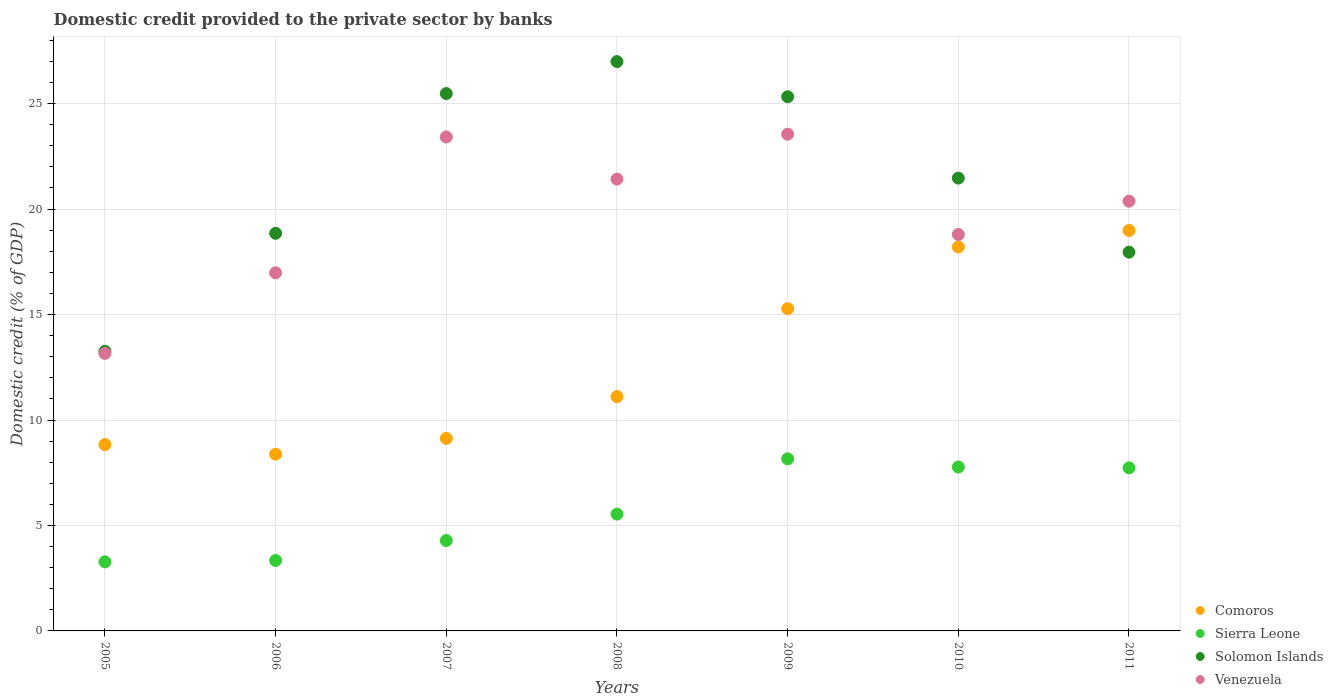Is the number of dotlines equal to the number of legend labels?
Keep it short and to the point. Yes. What is the domestic credit provided to the private sector by banks in Comoros in 2010?
Make the answer very short. 18.21. Across all years, what is the maximum domestic credit provided to the private sector by banks in Venezuela?
Your answer should be compact. 23.55. Across all years, what is the minimum domestic credit provided to the private sector by banks in Sierra Leone?
Your response must be concise. 3.28. In which year was the domestic credit provided to the private sector by banks in Solomon Islands maximum?
Offer a very short reply. 2008. In which year was the domestic credit provided to the private sector by banks in Sierra Leone minimum?
Make the answer very short. 2005. What is the total domestic credit provided to the private sector by banks in Solomon Islands in the graph?
Your answer should be very brief. 149.33. What is the difference between the domestic credit provided to the private sector by banks in Comoros in 2010 and that in 2011?
Make the answer very short. -0.78. What is the difference between the domestic credit provided to the private sector by banks in Sierra Leone in 2005 and the domestic credit provided to the private sector by banks in Venezuela in 2010?
Make the answer very short. -15.52. What is the average domestic credit provided to the private sector by banks in Sierra Leone per year?
Give a very brief answer. 5.73. In the year 2010, what is the difference between the domestic credit provided to the private sector by banks in Venezuela and domestic credit provided to the private sector by banks in Sierra Leone?
Provide a short and direct response. 11.03. In how many years, is the domestic credit provided to the private sector by banks in Sierra Leone greater than 27 %?
Your answer should be compact. 0. What is the ratio of the domestic credit provided to the private sector by banks in Solomon Islands in 2007 to that in 2008?
Keep it short and to the point. 0.94. Is the domestic credit provided to the private sector by banks in Solomon Islands in 2007 less than that in 2009?
Keep it short and to the point. No. Is the difference between the domestic credit provided to the private sector by banks in Venezuela in 2010 and 2011 greater than the difference between the domestic credit provided to the private sector by banks in Sierra Leone in 2010 and 2011?
Provide a succinct answer. No. What is the difference between the highest and the second highest domestic credit provided to the private sector by banks in Solomon Islands?
Your answer should be compact. 1.52. What is the difference between the highest and the lowest domestic credit provided to the private sector by banks in Comoros?
Your answer should be compact. 10.61. In how many years, is the domestic credit provided to the private sector by banks in Solomon Islands greater than the average domestic credit provided to the private sector by banks in Solomon Islands taken over all years?
Ensure brevity in your answer.  4. Is the sum of the domestic credit provided to the private sector by banks in Comoros in 2007 and 2008 greater than the maximum domestic credit provided to the private sector by banks in Solomon Islands across all years?
Keep it short and to the point. No. Is it the case that in every year, the sum of the domestic credit provided to the private sector by banks in Venezuela and domestic credit provided to the private sector by banks in Sierra Leone  is greater than the sum of domestic credit provided to the private sector by banks in Solomon Islands and domestic credit provided to the private sector by banks in Comoros?
Offer a very short reply. Yes. Is it the case that in every year, the sum of the domestic credit provided to the private sector by banks in Solomon Islands and domestic credit provided to the private sector by banks in Venezuela  is greater than the domestic credit provided to the private sector by banks in Sierra Leone?
Make the answer very short. Yes. Is the domestic credit provided to the private sector by banks in Venezuela strictly greater than the domestic credit provided to the private sector by banks in Sierra Leone over the years?
Provide a succinct answer. Yes. Is the domestic credit provided to the private sector by banks in Venezuela strictly less than the domestic credit provided to the private sector by banks in Sierra Leone over the years?
Provide a succinct answer. No. What is the difference between two consecutive major ticks on the Y-axis?
Your answer should be compact. 5. Does the graph contain grids?
Provide a succinct answer. Yes. How many legend labels are there?
Provide a succinct answer. 4. What is the title of the graph?
Provide a short and direct response. Domestic credit provided to the private sector by banks. What is the label or title of the Y-axis?
Offer a very short reply. Domestic credit (% of GDP). What is the Domestic credit (% of GDP) in Comoros in 2005?
Offer a terse response. 8.83. What is the Domestic credit (% of GDP) of Sierra Leone in 2005?
Provide a succinct answer. 3.28. What is the Domestic credit (% of GDP) of Solomon Islands in 2005?
Give a very brief answer. 13.25. What is the Domestic credit (% of GDP) in Venezuela in 2005?
Offer a terse response. 13.16. What is the Domestic credit (% of GDP) of Comoros in 2006?
Give a very brief answer. 8.38. What is the Domestic credit (% of GDP) of Sierra Leone in 2006?
Offer a terse response. 3.34. What is the Domestic credit (% of GDP) in Solomon Islands in 2006?
Keep it short and to the point. 18.85. What is the Domestic credit (% of GDP) of Venezuela in 2006?
Offer a very short reply. 16.98. What is the Domestic credit (% of GDP) in Comoros in 2007?
Your answer should be compact. 9.13. What is the Domestic credit (% of GDP) of Sierra Leone in 2007?
Offer a very short reply. 4.28. What is the Domestic credit (% of GDP) in Solomon Islands in 2007?
Provide a succinct answer. 25.48. What is the Domestic credit (% of GDP) in Venezuela in 2007?
Your answer should be very brief. 23.42. What is the Domestic credit (% of GDP) of Comoros in 2008?
Ensure brevity in your answer.  11.11. What is the Domestic credit (% of GDP) in Sierra Leone in 2008?
Offer a very short reply. 5.54. What is the Domestic credit (% of GDP) of Solomon Islands in 2008?
Make the answer very short. 26.99. What is the Domestic credit (% of GDP) of Venezuela in 2008?
Offer a very short reply. 21.42. What is the Domestic credit (% of GDP) of Comoros in 2009?
Keep it short and to the point. 15.28. What is the Domestic credit (% of GDP) in Sierra Leone in 2009?
Keep it short and to the point. 8.16. What is the Domestic credit (% of GDP) in Solomon Islands in 2009?
Your answer should be very brief. 25.33. What is the Domestic credit (% of GDP) of Venezuela in 2009?
Your answer should be compact. 23.55. What is the Domestic credit (% of GDP) of Comoros in 2010?
Provide a short and direct response. 18.21. What is the Domestic credit (% of GDP) in Sierra Leone in 2010?
Make the answer very short. 7.77. What is the Domestic credit (% of GDP) in Solomon Islands in 2010?
Make the answer very short. 21.47. What is the Domestic credit (% of GDP) in Venezuela in 2010?
Keep it short and to the point. 18.8. What is the Domestic credit (% of GDP) of Comoros in 2011?
Give a very brief answer. 18.99. What is the Domestic credit (% of GDP) of Sierra Leone in 2011?
Keep it short and to the point. 7.73. What is the Domestic credit (% of GDP) of Solomon Islands in 2011?
Your answer should be very brief. 17.96. What is the Domestic credit (% of GDP) in Venezuela in 2011?
Make the answer very short. 20.37. Across all years, what is the maximum Domestic credit (% of GDP) of Comoros?
Your answer should be very brief. 18.99. Across all years, what is the maximum Domestic credit (% of GDP) of Sierra Leone?
Your answer should be very brief. 8.16. Across all years, what is the maximum Domestic credit (% of GDP) in Solomon Islands?
Provide a succinct answer. 26.99. Across all years, what is the maximum Domestic credit (% of GDP) of Venezuela?
Your response must be concise. 23.55. Across all years, what is the minimum Domestic credit (% of GDP) in Comoros?
Give a very brief answer. 8.38. Across all years, what is the minimum Domestic credit (% of GDP) in Sierra Leone?
Provide a succinct answer. 3.28. Across all years, what is the minimum Domestic credit (% of GDP) in Solomon Islands?
Your answer should be compact. 13.25. Across all years, what is the minimum Domestic credit (% of GDP) of Venezuela?
Provide a short and direct response. 13.16. What is the total Domestic credit (% of GDP) in Comoros in the graph?
Offer a terse response. 89.92. What is the total Domestic credit (% of GDP) of Sierra Leone in the graph?
Offer a terse response. 40.1. What is the total Domestic credit (% of GDP) in Solomon Islands in the graph?
Your answer should be very brief. 149.33. What is the total Domestic credit (% of GDP) in Venezuela in the graph?
Offer a very short reply. 137.7. What is the difference between the Domestic credit (% of GDP) in Comoros in 2005 and that in 2006?
Your answer should be very brief. 0.45. What is the difference between the Domestic credit (% of GDP) of Sierra Leone in 2005 and that in 2006?
Ensure brevity in your answer.  -0.06. What is the difference between the Domestic credit (% of GDP) of Solomon Islands in 2005 and that in 2006?
Provide a succinct answer. -5.6. What is the difference between the Domestic credit (% of GDP) in Venezuela in 2005 and that in 2006?
Your response must be concise. -3.82. What is the difference between the Domestic credit (% of GDP) in Comoros in 2005 and that in 2007?
Offer a very short reply. -0.29. What is the difference between the Domestic credit (% of GDP) in Sierra Leone in 2005 and that in 2007?
Offer a terse response. -1.01. What is the difference between the Domestic credit (% of GDP) in Solomon Islands in 2005 and that in 2007?
Keep it short and to the point. -12.22. What is the difference between the Domestic credit (% of GDP) of Venezuela in 2005 and that in 2007?
Provide a succinct answer. -10.26. What is the difference between the Domestic credit (% of GDP) of Comoros in 2005 and that in 2008?
Give a very brief answer. -2.27. What is the difference between the Domestic credit (% of GDP) of Sierra Leone in 2005 and that in 2008?
Offer a very short reply. -2.26. What is the difference between the Domestic credit (% of GDP) in Solomon Islands in 2005 and that in 2008?
Your response must be concise. -13.74. What is the difference between the Domestic credit (% of GDP) in Venezuela in 2005 and that in 2008?
Offer a terse response. -8.26. What is the difference between the Domestic credit (% of GDP) in Comoros in 2005 and that in 2009?
Ensure brevity in your answer.  -6.44. What is the difference between the Domestic credit (% of GDP) of Sierra Leone in 2005 and that in 2009?
Provide a short and direct response. -4.88. What is the difference between the Domestic credit (% of GDP) in Solomon Islands in 2005 and that in 2009?
Your answer should be very brief. -12.07. What is the difference between the Domestic credit (% of GDP) of Venezuela in 2005 and that in 2009?
Provide a succinct answer. -10.39. What is the difference between the Domestic credit (% of GDP) in Comoros in 2005 and that in 2010?
Give a very brief answer. -9.37. What is the difference between the Domestic credit (% of GDP) of Sierra Leone in 2005 and that in 2010?
Offer a very short reply. -4.5. What is the difference between the Domestic credit (% of GDP) of Solomon Islands in 2005 and that in 2010?
Your answer should be very brief. -8.21. What is the difference between the Domestic credit (% of GDP) of Venezuela in 2005 and that in 2010?
Your response must be concise. -5.64. What is the difference between the Domestic credit (% of GDP) in Comoros in 2005 and that in 2011?
Offer a very short reply. -10.15. What is the difference between the Domestic credit (% of GDP) of Sierra Leone in 2005 and that in 2011?
Provide a succinct answer. -4.46. What is the difference between the Domestic credit (% of GDP) in Solomon Islands in 2005 and that in 2011?
Give a very brief answer. -4.7. What is the difference between the Domestic credit (% of GDP) of Venezuela in 2005 and that in 2011?
Offer a terse response. -7.22. What is the difference between the Domestic credit (% of GDP) in Comoros in 2006 and that in 2007?
Your answer should be very brief. -0.75. What is the difference between the Domestic credit (% of GDP) of Sierra Leone in 2006 and that in 2007?
Provide a succinct answer. -0.95. What is the difference between the Domestic credit (% of GDP) in Solomon Islands in 2006 and that in 2007?
Give a very brief answer. -6.63. What is the difference between the Domestic credit (% of GDP) in Venezuela in 2006 and that in 2007?
Make the answer very short. -6.44. What is the difference between the Domestic credit (% of GDP) of Comoros in 2006 and that in 2008?
Give a very brief answer. -2.73. What is the difference between the Domestic credit (% of GDP) in Sierra Leone in 2006 and that in 2008?
Keep it short and to the point. -2.2. What is the difference between the Domestic credit (% of GDP) of Solomon Islands in 2006 and that in 2008?
Provide a succinct answer. -8.14. What is the difference between the Domestic credit (% of GDP) of Venezuela in 2006 and that in 2008?
Your response must be concise. -4.44. What is the difference between the Domestic credit (% of GDP) in Comoros in 2006 and that in 2009?
Your answer should be compact. -6.9. What is the difference between the Domestic credit (% of GDP) of Sierra Leone in 2006 and that in 2009?
Provide a short and direct response. -4.82. What is the difference between the Domestic credit (% of GDP) in Solomon Islands in 2006 and that in 2009?
Ensure brevity in your answer.  -6.47. What is the difference between the Domestic credit (% of GDP) of Venezuela in 2006 and that in 2009?
Keep it short and to the point. -6.57. What is the difference between the Domestic credit (% of GDP) in Comoros in 2006 and that in 2010?
Your answer should be compact. -9.83. What is the difference between the Domestic credit (% of GDP) of Sierra Leone in 2006 and that in 2010?
Give a very brief answer. -4.43. What is the difference between the Domestic credit (% of GDP) in Solomon Islands in 2006 and that in 2010?
Your response must be concise. -2.62. What is the difference between the Domestic credit (% of GDP) in Venezuela in 2006 and that in 2010?
Provide a succinct answer. -1.82. What is the difference between the Domestic credit (% of GDP) in Comoros in 2006 and that in 2011?
Give a very brief answer. -10.61. What is the difference between the Domestic credit (% of GDP) in Sierra Leone in 2006 and that in 2011?
Keep it short and to the point. -4.39. What is the difference between the Domestic credit (% of GDP) in Solomon Islands in 2006 and that in 2011?
Give a very brief answer. 0.89. What is the difference between the Domestic credit (% of GDP) of Venezuela in 2006 and that in 2011?
Your answer should be compact. -3.39. What is the difference between the Domestic credit (% of GDP) in Comoros in 2007 and that in 2008?
Provide a succinct answer. -1.98. What is the difference between the Domestic credit (% of GDP) of Sierra Leone in 2007 and that in 2008?
Provide a succinct answer. -1.25. What is the difference between the Domestic credit (% of GDP) in Solomon Islands in 2007 and that in 2008?
Your answer should be compact. -1.52. What is the difference between the Domestic credit (% of GDP) in Venezuela in 2007 and that in 2008?
Your answer should be compact. 2. What is the difference between the Domestic credit (% of GDP) in Comoros in 2007 and that in 2009?
Your answer should be compact. -6.15. What is the difference between the Domestic credit (% of GDP) in Sierra Leone in 2007 and that in 2009?
Provide a succinct answer. -3.87. What is the difference between the Domestic credit (% of GDP) of Solomon Islands in 2007 and that in 2009?
Give a very brief answer. 0.15. What is the difference between the Domestic credit (% of GDP) in Venezuela in 2007 and that in 2009?
Give a very brief answer. -0.13. What is the difference between the Domestic credit (% of GDP) of Comoros in 2007 and that in 2010?
Give a very brief answer. -9.08. What is the difference between the Domestic credit (% of GDP) in Sierra Leone in 2007 and that in 2010?
Your answer should be compact. -3.49. What is the difference between the Domestic credit (% of GDP) of Solomon Islands in 2007 and that in 2010?
Ensure brevity in your answer.  4.01. What is the difference between the Domestic credit (% of GDP) in Venezuela in 2007 and that in 2010?
Provide a succinct answer. 4.62. What is the difference between the Domestic credit (% of GDP) in Comoros in 2007 and that in 2011?
Offer a terse response. -9.86. What is the difference between the Domestic credit (% of GDP) of Sierra Leone in 2007 and that in 2011?
Your answer should be compact. -3.45. What is the difference between the Domestic credit (% of GDP) in Solomon Islands in 2007 and that in 2011?
Ensure brevity in your answer.  7.52. What is the difference between the Domestic credit (% of GDP) in Venezuela in 2007 and that in 2011?
Make the answer very short. 3.05. What is the difference between the Domestic credit (% of GDP) of Comoros in 2008 and that in 2009?
Your answer should be very brief. -4.17. What is the difference between the Domestic credit (% of GDP) of Sierra Leone in 2008 and that in 2009?
Offer a terse response. -2.62. What is the difference between the Domestic credit (% of GDP) of Solomon Islands in 2008 and that in 2009?
Offer a terse response. 1.67. What is the difference between the Domestic credit (% of GDP) of Venezuela in 2008 and that in 2009?
Keep it short and to the point. -2.13. What is the difference between the Domestic credit (% of GDP) of Comoros in 2008 and that in 2010?
Offer a terse response. -7.1. What is the difference between the Domestic credit (% of GDP) of Sierra Leone in 2008 and that in 2010?
Offer a very short reply. -2.23. What is the difference between the Domestic credit (% of GDP) in Solomon Islands in 2008 and that in 2010?
Ensure brevity in your answer.  5.52. What is the difference between the Domestic credit (% of GDP) in Venezuela in 2008 and that in 2010?
Offer a terse response. 2.62. What is the difference between the Domestic credit (% of GDP) of Comoros in 2008 and that in 2011?
Keep it short and to the point. -7.88. What is the difference between the Domestic credit (% of GDP) in Sierra Leone in 2008 and that in 2011?
Offer a very short reply. -2.19. What is the difference between the Domestic credit (% of GDP) in Solomon Islands in 2008 and that in 2011?
Provide a short and direct response. 9.04. What is the difference between the Domestic credit (% of GDP) of Venezuela in 2008 and that in 2011?
Give a very brief answer. 1.05. What is the difference between the Domestic credit (% of GDP) in Comoros in 2009 and that in 2010?
Give a very brief answer. -2.93. What is the difference between the Domestic credit (% of GDP) of Sierra Leone in 2009 and that in 2010?
Offer a very short reply. 0.39. What is the difference between the Domestic credit (% of GDP) of Solomon Islands in 2009 and that in 2010?
Give a very brief answer. 3.86. What is the difference between the Domestic credit (% of GDP) of Venezuela in 2009 and that in 2010?
Offer a terse response. 4.75. What is the difference between the Domestic credit (% of GDP) of Comoros in 2009 and that in 2011?
Offer a very short reply. -3.71. What is the difference between the Domestic credit (% of GDP) in Sierra Leone in 2009 and that in 2011?
Ensure brevity in your answer.  0.43. What is the difference between the Domestic credit (% of GDP) in Solomon Islands in 2009 and that in 2011?
Your answer should be compact. 7.37. What is the difference between the Domestic credit (% of GDP) in Venezuela in 2009 and that in 2011?
Offer a terse response. 3.18. What is the difference between the Domestic credit (% of GDP) in Comoros in 2010 and that in 2011?
Provide a short and direct response. -0.78. What is the difference between the Domestic credit (% of GDP) of Sierra Leone in 2010 and that in 2011?
Make the answer very short. 0.04. What is the difference between the Domestic credit (% of GDP) of Solomon Islands in 2010 and that in 2011?
Provide a short and direct response. 3.51. What is the difference between the Domestic credit (% of GDP) in Venezuela in 2010 and that in 2011?
Your answer should be very brief. -1.58. What is the difference between the Domestic credit (% of GDP) in Comoros in 2005 and the Domestic credit (% of GDP) in Sierra Leone in 2006?
Give a very brief answer. 5.5. What is the difference between the Domestic credit (% of GDP) in Comoros in 2005 and the Domestic credit (% of GDP) in Solomon Islands in 2006?
Your answer should be very brief. -10.02. What is the difference between the Domestic credit (% of GDP) of Comoros in 2005 and the Domestic credit (% of GDP) of Venezuela in 2006?
Your answer should be compact. -8.15. What is the difference between the Domestic credit (% of GDP) of Sierra Leone in 2005 and the Domestic credit (% of GDP) of Solomon Islands in 2006?
Provide a succinct answer. -15.58. What is the difference between the Domestic credit (% of GDP) of Sierra Leone in 2005 and the Domestic credit (% of GDP) of Venezuela in 2006?
Make the answer very short. -13.7. What is the difference between the Domestic credit (% of GDP) in Solomon Islands in 2005 and the Domestic credit (% of GDP) in Venezuela in 2006?
Provide a succinct answer. -3.72. What is the difference between the Domestic credit (% of GDP) in Comoros in 2005 and the Domestic credit (% of GDP) in Sierra Leone in 2007?
Provide a succinct answer. 4.55. What is the difference between the Domestic credit (% of GDP) in Comoros in 2005 and the Domestic credit (% of GDP) in Solomon Islands in 2007?
Give a very brief answer. -16.64. What is the difference between the Domestic credit (% of GDP) in Comoros in 2005 and the Domestic credit (% of GDP) in Venezuela in 2007?
Offer a very short reply. -14.59. What is the difference between the Domestic credit (% of GDP) of Sierra Leone in 2005 and the Domestic credit (% of GDP) of Solomon Islands in 2007?
Provide a short and direct response. -22.2. What is the difference between the Domestic credit (% of GDP) of Sierra Leone in 2005 and the Domestic credit (% of GDP) of Venezuela in 2007?
Keep it short and to the point. -20.14. What is the difference between the Domestic credit (% of GDP) in Solomon Islands in 2005 and the Domestic credit (% of GDP) in Venezuela in 2007?
Your answer should be very brief. -10.17. What is the difference between the Domestic credit (% of GDP) in Comoros in 2005 and the Domestic credit (% of GDP) in Sierra Leone in 2008?
Keep it short and to the point. 3.3. What is the difference between the Domestic credit (% of GDP) of Comoros in 2005 and the Domestic credit (% of GDP) of Solomon Islands in 2008?
Keep it short and to the point. -18.16. What is the difference between the Domestic credit (% of GDP) in Comoros in 2005 and the Domestic credit (% of GDP) in Venezuela in 2008?
Your answer should be compact. -12.59. What is the difference between the Domestic credit (% of GDP) in Sierra Leone in 2005 and the Domestic credit (% of GDP) in Solomon Islands in 2008?
Give a very brief answer. -23.72. What is the difference between the Domestic credit (% of GDP) of Sierra Leone in 2005 and the Domestic credit (% of GDP) of Venezuela in 2008?
Your answer should be compact. -18.15. What is the difference between the Domestic credit (% of GDP) in Solomon Islands in 2005 and the Domestic credit (% of GDP) in Venezuela in 2008?
Provide a short and direct response. -8.17. What is the difference between the Domestic credit (% of GDP) of Comoros in 2005 and the Domestic credit (% of GDP) of Sierra Leone in 2009?
Ensure brevity in your answer.  0.68. What is the difference between the Domestic credit (% of GDP) of Comoros in 2005 and the Domestic credit (% of GDP) of Solomon Islands in 2009?
Provide a succinct answer. -16.49. What is the difference between the Domestic credit (% of GDP) of Comoros in 2005 and the Domestic credit (% of GDP) of Venezuela in 2009?
Give a very brief answer. -14.72. What is the difference between the Domestic credit (% of GDP) in Sierra Leone in 2005 and the Domestic credit (% of GDP) in Solomon Islands in 2009?
Your response must be concise. -22.05. What is the difference between the Domestic credit (% of GDP) in Sierra Leone in 2005 and the Domestic credit (% of GDP) in Venezuela in 2009?
Provide a succinct answer. -20.28. What is the difference between the Domestic credit (% of GDP) of Solomon Islands in 2005 and the Domestic credit (% of GDP) of Venezuela in 2009?
Your response must be concise. -10.3. What is the difference between the Domestic credit (% of GDP) of Comoros in 2005 and the Domestic credit (% of GDP) of Sierra Leone in 2010?
Keep it short and to the point. 1.06. What is the difference between the Domestic credit (% of GDP) in Comoros in 2005 and the Domestic credit (% of GDP) in Solomon Islands in 2010?
Make the answer very short. -12.63. What is the difference between the Domestic credit (% of GDP) in Comoros in 2005 and the Domestic credit (% of GDP) in Venezuela in 2010?
Offer a very short reply. -9.96. What is the difference between the Domestic credit (% of GDP) in Sierra Leone in 2005 and the Domestic credit (% of GDP) in Solomon Islands in 2010?
Your answer should be compact. -18.19. What is the difference between the Domestic credit (% of GDP) in Sierra Leone in 2005 and the Domestic credit (% of GDP) in Venezuela in 2010?
Provide a short and direct response. -15.52. What is the difference between the Domestic credit (% of GDP) of Solomon Islands in 2005 and the Domestic credit (% of GDP) of Venezuela in 2010?
Offer a very short reply. -5.54. What is the difference between the Domestic credit (% of GDP) of Comoros in 2005 and the Domestic credit (% of GDP) of Sierra Leone in 2011?
Your answer should be compact. 1.1. What is the difference between the Domestic credit (% of GDP) in Comoros in 2005 and the Domestic credit (% of GDP) in Solomon Islands in 2011?
Provide a short and direct response. -9.12. What is the difference between the Domestic credit (% of GDP) in Comoros in 2005 and the Domestic credit (% of GDP) in Venezuela in 2011?
Provide a short and direct response. -11.54. What is the difference between the Domestic credit (% of GDP) in Sierra Leone in 2005 and the Domestic credit (% of GDP) in Solomon Islands in 2011?
Keep it short and to the point. -14.68. What is the difference between the Domestic credit (% of GDP) in Sierra Leone in 2005 and the Domestic credit (% of GDP) in Venezuela in 2011?
Ensure brevity in your answer.  -17.1. What is the difference between the Domestic credit (% of GDP) in Solomon Islands in 2005 and the Domestic credit (% of GDP) in Venezuela in 2011?
Give a very brief answer. -7.12. What is the difference between the Domestic credit (% of GDP) of Comoros in 2006 and the Domestic credit (% of GDP) of Sierra Leone in 2007?
Keep it short and to the point. 4.09. What is the difference between the Domestic credit (% of GDP) in Comoros in 2006 and the Domestic credit (% of GDP) in Solomon Islands in 2007?
Provide a short and direct response. -17.1. What is the difference between the Domestic credit (% of GDP) in Comoros in 2006 and the Domestic credit (% of GDP) in Venezuela in 2007?
Ensure brevity in your answer.  -15.04. What is the difference between the Domestic credit (% of GDP) in Sierra Leone in 2006 and the Domestic credit (% of GDP) in Solomon Islands in 2007?
Make the answer very short. -22.14. What is the difference between the Domestic credit (% of GDP) in Sierra Leone in 2006 and the Domestic credit (% of GDP) in Venezuela in 2007?
Offer a terse response. -20.08. What is the difference between the Domestic credit (% of GDP) of Solomon Islands in 2006 and the Domestic credit (% of GDP) of Venezuela in 2007?
Offer a very short reply. -4.57. What is the difference between the Domestic credit (% of GDP) in Comoros in 2006 and the Domestic credit (% of GDP) in Sierra Leone in 2008?
Offer a terse response. 2.84. What is the difference between the Domestic credit (% of GDP) in Comoros in 2006 and the Domestic credit (% of GDP) in Solomon Islands in 2008?
Your response must be concise. -18.61. What is the difference between the Domestic credit (% of GDP) of Comoros in 2006 and the Domestic credit (% of GDP) of Venezuela in 2008?
Offer a terse response. -13.04. What is the difference between the Domestic credit (% of GDP) in Sierra Leone in 2006 and the Domestic credit (% of GDP) in Solomon Islands in 2008?
Keep it short and to the point. -23.65. What is the difference between the Domestic credit (% of GDP) of Sierra Leone in 2006 and the Domestic credit (% of GDP) of Venezuela in 2008?
Your response must be concise. -18.08. What is the difference between the Domestic credit (% of GDP) in Solomon Islands in 2006 and the Domestic credit (% of GDP) in Venezuela in 2008?
Offer a terse response. -2.57. What is the difference between the Domestic credit (% of GDP) of Comoros in 2006 and the Domestic credit (% of GDP) of Sierra Leone in 2009?
Your answer should be very brief. 0.22. What is the difference between the Domestic credit (% of GDP) in Comoros in 2006 and the Domestic credit (% of GDP) in Solomon Islands in 2009?
Offer a terse response. -16.95. What is the difference between the Domestic credit (% of GDP) of Comoros in 2006 and the Domestic credit (% of GDP) of Venezuela in 2009?
Ensure brevity in your answer.  -15.17. What is the difference between the Domestic credit (% of GDP) of Sierra Leone in 2006 and the Domestic credit (% of GDP) of Solomon Islands in 2009?
Keep it short and to the point. -21.99. What is the difference between the Domestic credit (% of GDP) of Sierra Leone in 2006 and the Domestic credit (% of GDP) of Venezuela in 2009?
Keep it short and to the point. -20.21. What is the difference between the Domestic credit (% of GDP) in Solomon Islands in 2006 and the Domestic credit (% of GDP) in Venezuela in 2009?
Offer a terse response. -4.7. What is the difference between the Domestic credit (% of GDP) of Comoros in 2006 and the Domestic credit (% of GDP) of Sierra Leone in 2010?
Your response must be concise. 0.61. What is the difference between the Domestic credit (% of GDP) in Comoros in 2006 and the Domestic credit (% of GDP) in Solomon Islands in 2010?
Give a very brief answer. -13.09. What is the difference between the Domestic credit (% of GDP) in Comoros in 2006 and the Domestic credit (% of GDP) in Venezuela in 2010?
Your answer should be very brief. -10.42. What is the difference between the Domestic credit (% of GDP) in Sierra Leone in 2006 and the Domestic credit (% of GDP) in Solomon Islands in 2010?
Provide a succinct answer. -18.13. What is the difference between the Domestic credit (% of GDP) of Sierra Leone in 2006 and the Domestic credit (% of GDP) of Venezuela in 2010?
Provide a short and direct response. -15.46. What is the difference between the Domestic credit (% of GDP) in Solomon Islands in 2006 and the Domestic credit (% of GDP) in Venezuela in 2010?
Make the answer very short. 0.05. What is the difference between the Domestic credit (% of GDP) of Comoros in 2006 and the Domestic credit (% of GDP) of Sierra Leone in 2011?
Make the answer very short. 0.65. What is the difference between the Domestic credit (% of GDP) of Comoros in 2006 and the Domestic credit (% of GDP) of Solomon Islands in 2011?
Keep it short and to the point. -9.58. What is the difference between the Domestic credit (% of GDP) of Comoros in 2006 and the Domestic credit (% of GDP) of Venezuela in 2011?
Your response must be concise. -11.99. What is the difference between the Domestic credit (% of GDP) in Sierra Leone in 2006 and the Domestic credit (% of GDP) in Solomon Islands in 2011?
Provide a short and direct response. -14.62. What is the difference between the Domestic credit (% of GDP) in Sierra Leone in 2006 and the Domestic credit (% of GDP) in Venezuela in 2011?
Ensure brevity in your answer.  -17.04. What is the difference between the Domestic credit (% of GDP) of Solomon Islands in 2006 and the Domestic credit (% of GDP) of Venezuela in 2011?
Keep it short and to the point. -1.52. What is the difference between the Domestic credit (% of GDP) in Comoros in 2007 and the Domestic credit (% of GDP) in Sierra Leone in 2008?
Offer a terse response. 3.59. What is the difference between the Domestic credit (% of GDP) in Comoros in 2007 and the Domestic credit (% of GDP) in Solomon Islands in 2008?
Offer a very short reply. -17.87. What is the difference between the Domestic credit (% of GDP) in Comoros in 2007 and the Domestic credit (% of GDP) in Venezuela in 2008?
Keep it short and to the point. -12.29. What is the difference between the Domestic credit (% of GDP) of Sierra Leone in 2007 and the Domestic credit (% of GDP) of Solomon Islands in 2008?
Provide a short and direct response. -22.71. What is the difference between the Domestic credit (% of GDP) in Sierra Leone in 2007 and the Domestic credit (% of GDP) in Venezuela in 2008?
Your response must be concise. -17.14. What is the difference between the Domestic credit (% of GDP) in Solomon Islands in 2007 and the Domestic credit (% of GDP) in Venezuela in 2008?
Give a very brief answer. 4.06. What is the difference between the Domestic credit (% of GDP) in Comoros in 2007 and the Domestic credit (% of GDP) in Sierra Leone in 2009?
Provide a succinct answer. 0.97. What is the difference between the Domestic credit (% of GDP) of Comoros in 2007 and the Domestic credit (% of GDP) of Solomon Islands in 2009?
Provide a succinct answer. -16.2. What is the difference between the Domestic credit (% of GDP) in Comoros in 2007 and the Domestic credit (% of GDP) in Venezuela in 2009?
Offer a terse response. -14.42. What is the difference between the Domestic credit (% of GDP) of Sierra Leone in 2007 and the Domestic credit (% of GDP) of Solomon Islands in 2009?
Your response must be concise. -21.04. What is the difference between the Domestic credit (% of GDP) in Sierra Leone in 2007 and the Domestic credit (% of GDP) in Venezuela in 2009?
Provide a short and direct response. -19.27. What is the difference between the Domestic credit (% of GDP) in Solomon Islands in 2007 and the Domestic credit (% of GDP) in Venezuela in 2009?
Keep it short and to the point. 1.93. What is the difference between the Domestic credit (% of GDP) of Comoros in 2007 and the Domestic credit (% of GDP) of Sierra Leone in 2010?
Ensure brevity in your answer.  1.36. What is the difference between the Domestic credit (% of GDP) in Comoros in 2007 and the Domestic credit (% of GDP) in Solomon Islands in 2010?
Ensure brevity in your answer.  -12.34. What is the difference between the Domestic credit (% of GDP) of Comoros in 2007 and the Domestic credit (% of GDP) of Venezuela in 2010?
Offer a very short reply. -9.67. What is the difference between the Domestic credit (% of GDP) in Sierra Leone in 2007 and the Domestic credit (% of GDP) in Solomon Islands in 2010?
Your answer should be very brief. -17.18. What is the difference between the Domestic credit (% of GDP) in Sierra Leone in 2007 and the Domestic credit (% of GDP) in Venezuela in 2010?
Provide a succinct answer. -14.51. What is the difference between the Domestic credit (% of GDP) of Solomon Islands in 2007 and the Domestic credit (% of GDP) of Venezuela in 2010?
Your answer should be very brief. 6.68. What is the difference between the Domestic credit (% of GDP) in Comoros in 2007 and the Domestic credit (% of GDP) in Sierra Leone in 2011?
Give a very brief answer. 1.39. What is the difference between the Domestic credit (% of GDP) in Comoros in 2007 and the Domestic credit (% of GDP) in Solomon Islands in 2011?
Offer a very short reply. -8.83. What is the difference between the Domestic credit (% of GDP) in Comoros in 2007 and the Domestic credit (% of GDP) in Venezuela in 2011?
Give a very brief answer. -11.25. What is the difference between the Domestic credit (% of GDP) in Sierra Leone in 2007 and the Domestic credit (% of GDP) in Solomon Islands in 2011?
Make the answer very short. -13.67. What is the difference between the Domestic credit (% of GDP) in Sierra Leone in 2007 and the Domestic credit (% of GDP) in Venezuela in 2011?
Keep it short and to the point. -16.09. What is the difference between the Domestic credit (% of GDP) of Solomon Islands in 2007 and the Domestic credit (% of GDP) of Venezuela in 2011?
Your answer should be compact. 5.1. What is the difference between the Domestic credit (% of GDP) in Comoros in 2008 and the Domestic credit (% of GDP) in Sierra Leone in 2009?
Your answer should be compact. 2.95. What is the difference between the Domestic credit (% of GDP) of Comoros in 2008 and the Domestic credit (% of GDP) of Solomon Islands in 2009?
Provide a succinct answer. -14.22. What is the difference between the Domestic credit (% of GDP) of Comoros in 2008 and the Domestic credit (% of GDP) of Venezuela in 2009?
Your response must be concise. -12.44. What is the difference between the Domestic credit (% of GDP) in Sierra Leone in 2008 and the Domestic credit (% of GDP) in Solomon Islands in 2009?
Provide a short and direct response. -19.79. What is the difference between the Domestic credit (% of GDP) of Sierra Leone in 2008 and the Domestic credit (% of GDP) of Venezuela in 2009?
Your answer should be compact. -18.01. What is the difference between the Domestic credit (% of GDP) in Solomon Islands in 2008 and the Domestic credit (% of GDP) in Venezuela in 2009?
Offer a terse response. 3.44. What is the difference between the Domestic credit (% of GDP) in Comoros in 2008 and the Domestic credit (% of GDP) in Sierra Leone in 2010?
Provide a short and direct response. 3.34. What is the difference between the Domestic credit (% of GDP) in Comoros in 2008 and the Domestic credit (% of GDP) in Solomon Islands in 2010?
Offer a terse response. -10.36. What is the difference between the Domestic credit (% of GDP) in Comoros in 2008 and the Domestic credit (% of GDP) in Venezuela in 2010?
Keep it short and to the point. -7.69. What is the difference between the Domestic credit (% of GDP) in Sierra Leone in 2008 and the Domestic credit (% of GDP) in Solomon Islands in 2010?
Your answer should be very brief. -15.93. What is the difference between the Domestic credit (% of GDP) in Sierra Leone in 2008 and the Domestic credit (% of GDP) in Venezuela in 2010?
Provide a succinct answer. -13.26. What is the difference between the Domestic credit (% of GDP) of Solomon Islands in 2008 and the Domestic credit (% of GDP) of Venezuela in 2010?
Make the answer very short. 8.2. What is the difference between the Domestic credit (% of GDP) in Comoros in 2008 and the Domestic credit (% of GDP) in Sierra Leone in 2011?
Provide a short and direct response. 3.38. What is the difference between the Domestic credit (% of GDP) in Comoros in 2008 and the Domestic credit (% of GDP) in Solomon Islands in 2011?
Keep it short and to the point. -6.85. What is the difference between the Domestic credit (% of GDP) of Comoros in 2008 and the Domestic credit (% of GDP) of Venezuela in 2011?
Offer a very short reply. -9.27. What is the difference between the Domestic credit (% of GDP) in Sierra Leone in 2008 and the Domestic credit (% of GDP) in Solomon Islands in 2011?
Give a very brief answer. -12.42. What is the difference between the Domestic credit (% of GDP) of Sierra Leone in 2008 and the Domestic credit (% of GDP) of Venezuela in 2011?
Offer a very short reply. -14.84. What is the difference between the Domestic credit (% of GDP) of Solomon Islands in 2008 and the Domestic credit (% of GDP) of Venezuela in 2011?
Provide a short and direct response. 6.62. What is the difference between the Domestic credit (% of GDP) in Comoros in 2009 and the Domestic credit (% of GDP) in Sierra Leone in 2010?
Provide a succinct answer. 7.5. What is the difference between the Domestic credit (% of GDP) in Comoros in 2009 and the Domestic credit (% of GDP) in Solomon Islands in 2010?
Give a very brief answer. -6.19. What is the difference between the Domestic credit (% of GDP) of Comoros in 2009 and the Domestic credit (% of GDP) of Venezuela in 2010?
Provide a succinct answer. -3.52. What is the difference between the Domestic credit (% of GDP) in Sierra Leone in 2009 and the Domestic credit (% of GDP) in Solomon Islands in 2010?
Offer a very short reply. -13.31. What is the difference between the Domestic credit (% of GDP) of Sierra Leone in 2009 and the Domestic credit (% of GDP) of Venezuela in 2010?
Give a very brief answer. -10.64. What is the difference between the Domestic credit (% of GDP) in Solomon Islands in 2009 and the Domestic credit (% of GDP) in Venezuela in 2010?
Your answer should be very brief. 6.53. What is the difference between the Domestic credit (% of GDP) of Comoros in 2009 and the Domestic credit (% of GDP) of Sierra Leone in 2011?
Your answer should be compact. 7.54. What is the difference between the Domestic credit (% of GDP) in Comoros in 2009 and the Domestic credit (% of GDP) in Solomon Islands in 2011?
Offer a very short reply. -2.68. What is the difference between the Domestic credit (% of GDP) of Comoros in 2009 and the Domestic credit (% of GDP) of Venezuela in 2011?
Your answer should be compact. -5.1. What is the difference between the Domestic credit (% of GDP) of Sierra Leone in 2009 and the Domestic credit (% of GDP) of Solomon Islands in 2011?
Provide a short and direct response. -9.8. What is the difference between the Domestic credit (% of GDP) in Sierra Leone in 2009 and the Domestic credit (% of GDP) in Venezuela in 2011?
Give a very brief answer. -12.22. What is the difference between the Domestic credit (% of GDP) of Solomon Islands in 2009 and the Domestic credit (% of GDP) of Venezuela in 2011?
Ensure brevity in your answer.  4.95. What is the difference between the Domestic credit (% of GDP) in Comoros in 2010 and the Domestic credit (% of GDP) in Sierra Leone in 2011?
Provide a succinct answer. 10.47. What is the difference between the Domestic credit (% of GDP) of Comoros in 2010 and the Domestic credit (% of GDP) of Solomon Islands in 2011?
Provide a short and direct response. 0.25. What is the difference between the Domestic credit (% of GDP) of Comoros in 2010 and the Domestic credit (% of GDP) of Venezuela in 2011?
Your answer should be very brief. -2.17. What is the difference between the Domestic credit (% of GDP) in Sierra Leone in 2010 and the Domestic credit (% of GDP) in Solomon Islands in 2011?
Your answer should be compact. -10.19. What is the difference between the Domestic credit (% of GDP) of Sierra Leone in 2010 and the Domestic credit (% of GDP) of Venezuela in 2011?
Offer a terse response. -12.6. What is the difference between the Domestic credit (% of GDP) in Solomon Islands in 2010 and the Domestic credit (% of GDP) in Venezuela in 2011?
Give a very brief answer. 1.09. What is the average Domestic credit (% of GDP) in Comoros per year?
Your answer should be compact. 12.85. What is the average Domestic credit (% of GDP) of Sierra Leone per year?
Give a very brief answer. 5.73. What is the average Domestic credit (% of GDP) in Solomon Islands per year?
Make the answer very short. 21.33. What is the average Domestic credit (% of GDP) of Venezuela per year?
Your response must be concise. 19.67. In the year 2005, what is the difference between the Domestic credit (% of GDP) in Comoros and Domestic credit (% of GDP) in Sierra Leone?
Provide a succinct answer. 5.56. In the year 2005, what is the difference between the Domestic credit (% of GDP) in Comoros and Domestic credit (% of GDP) in Solomon Islands?
Make the answer very short. -4.42. In the year 2005, what is the difference between the Domestic credit (% of GDP) in Comoros and Domestic credit (% of GDP) in Venezuela?
Offer a terse response. -4.33. In the year 2005, what is the difference between the Domestic credit (% of GDP) of Sierra Leone and Domestic credit (% of GDP) of Solomon Islands?
Provide a short and direct response. -9.98. In the year 2005, what is the difference between the Domestic credit (% of GDP) of Sierra Leone and Domestic credit (% of GDP) of Venezuela?
Provide a short and direct response. -9.88. In the year 2005, what is the difference between the Domestic credit (% of GDP) of Solomon Islands and Domestic credit (% of GDP) of Venezuela?
Give a very brief answer. 0.1. In the year 2006, what is the difference between the Domestic credit (% of GDP) of Comoros and Domestic credit (% of GDP) of Sierra Leone?
Your response must be concise. 5.04. In the year 2006, what is the difference between the Domestic credit (% of GDP) of Comoros and Domestic credit (% of GDP) of Solomon Islands?
Keep it short and to the point. -10.47. In the year 2006, what is the difference between the Domestic credit (% of GDP) of Comoros and Domestic credit (% of GDP) of Venezuela?
Make the answer very short. -8.6. In the year 2006, what is the difference between the Domestic credit (% of GDP) of Sierra Leone and Domestic credit (% of GDP) of Solomon Islands?
Ensure brevity in your answer.  -15.51. In the year 2006, what is the difference between the Domestic credit (% of GDP) of Sierra Leone and Domestic credit (% of GDP) of Venezuela?
Keep it short and to the point. -13.64. In the year 2006, what is the difference between the Domestic credit (% of GDP) in Solomon Islands and Domestic credit (% of GDP) in Venezuela?
Keep it short and to the point. 1.87. In the year 2007, what is the difference between the Domestic credit (% of GDP) of Comoros and Domestic credit (% of GDP) of Sierra Leone?
Provide a succinct answer. 4.84. In the year 2007, what is the difference between the Domestic credit (% of GDP) in Comoros and Domestic credit (% of GDP) in Solomon Islands?
Provide a succinct answer. -16.35. In the year 2007, what is the difference between the Domestic credit (% of GDP) of Comoros and Domestic credit (% of GDP) of Venezuela?
Provide a succinct answer. -14.29. In the year 2007, what is the difference between the Domestic credit (% of GDP) of Sierra Leone and Domestic credit (% of GDP) of Solomon Islands?
Ensure brevity in your answer.  -21.19. In the year 2007, what is the difference between the Domestic credit (% of GDP) of Sierra Leone and Domestic credit (% of GDP) of Venezuela?
Provide a succinct answer. -19.14. In the year 2007, what is the difference between the Domestic credit (% of GDP) of Solomon Islands and Domestic credit (% of GDP) of Venezuela?
Your answer should be very brief. 2.06. In the year 2008, what is the difference between the Domestic credit (% of GDP) of Comoros and Domestic credit (% of GDP) of Sierra Leone?
Offer a very short reply. 5.57. In the year 2008, what is the difference between the Domestic credit (% of GDP) in Comoros and Domestic credit (% of GDP) in Solomon Islands?
Your answer should be compact. -15.89. In the year 2008, what is the difference between the Domestic credit (% of GDP) in Comoros and Domestic credit (% of GDP) in Venezuela?
Your answer should be very brief. -10.31. In the year 2008, what is the difference between the Domestic credit (% of GDP) in Sierra Leone and Domestic credit (% of GDP) in Solomon Islands?
Your response must be concise. -21.45. In the year 2008, what is the difference between the Domestic credit (% of GDP) of Sierra Leone and Domestic credit (% of GDP) of Venezuela?
Your answer should be compact. -15.88. In the year 2008, what is the difference between the Domestic credit (% of GDP) in Solomon Islands and Domestic credit (% of GDP) in Venezuela?
Your response must be concise. 5.57. In the year 2009, what is the difference between the Domestic credit (% of GDP) in Comoros and Domestic credit (% of GDP) in Sierra Leone?
Offer a very short reply. 7.12. In the year 2009, what is the difference between the Domestic credit (% of GDP) in Comoros and Domestic credit (% of GDP) in Solomon Islands?
Keep it short and to the point. -10.05. In the year 2009, what is the difference between the Domestic credit (% of GDP) of Comoros and Domestic credit (% of GDP) of Venezuela?
Your answer should be very brief. -8.27. In the year 2009, what is the difference between the Domestic credit (% of GDP) of Sierra Leone and Domestic credit (% of GDP) of Solomon Islands?
Offer a terse response. -17.17. In the year 2009, what is the difference between the Domestic credit (% of GDP) in Sierra Leone and Domestic credit (% of GDP) in Venezuela?
Provide a succinct answer. -15.39. In the year 2009, what is the difference between the Domestic credit (% of GDP) of Solomon Islands and Domestic credit (% of GDP) of Venezuela?
Give a very brief answer. 1.78. In the year 2010, what is the difference between the Domestic credit (% of GDP) in Comoros and Domestic credit (% of GDP) in Sierra Leone?
Provide a short and direct response. 10.43. In the year 2010, what is the difference between the Domestic credit (% of GDP) of Comoros and Domestic credit (% of GDP) of Solomon Islands?
Ensure brevity in your answer.  -3.26. In the year 2010, what is the difference between the Domestic credit (% of GDP) of Comoros and Domestic credit (% of GDP) of Venezuela?
Your answer should be compact. -0.59. In the year 2010, what is the difference between the Domestic credit (% of GDP) of Sierra Leone and Domestic credit (% of GDP) of Solomon Islands?
Keep it short and to the point. -13.7. In the year 2010, what is the difference between the Domestic credit (% of GDP) in Sierra Leone and Domestic credit (% of GDP) in Venezuela?
Give a very brief answer. -11.03. In the year 2010, what is the difference between the Domestic credit (% of GDP) of Solomon Islands and Domestic credit (% of GDP) of Venezuela?
Keep it short and to the point. 2.67. In the year 2011, what is the difference between the Domestic credit (% of GDP) of Comoros and Domestic credit (% of GDP) of Sierra Leone?
Your response must be concise. 11.25. In the year 2011, what is the difference between the Domestic credit (% of GDP) of Comoros and Domestic credit (% of GDP) of Solomon Islands?
Your answer should be compact. 1.03. In the year 2011, what is the difference between the Domestic credit (% of GDP) of Comoros and Domestic credit (% of GDP) of Venezuela?
Offer a terse response. -1.39. In the year 2011, what is the difference between the Domestic credit (% of GDP) in Sierra Leone and Domestic credit (% of GDP) in Solomon Islands?
Offer a terse response. -10.23. In the year 2011, what is the difference between the Domestic credit (% of GDP) in Sierra Leone and Domestic credit (% of GDP) in Venezuela?
Your answer should be compact. -12.64. In the year 2011, what is the difference between the Domestic credit (% of GDP) in Solomon Islands and Domestic credit (% of GDP) in Venezuela?
Provide a short and direct response. -2.42. What is the ratio of the Domestic credit (% of GDP) in Comoros in 2005 to that in 2006?
Offer a very short reply. 1.05. What is the ratio of the Domestic credit (% of GDP) in Sierra Leone in 2005 to that in 2006?
Keep it short and to the point. 0.98. What is the ratio of the Domestic credit (% of GDP) of Solomon Islands in 2005 to that in 2006?
Make the answer very short. 0.7. What is the ratio of the Domestic credit (% of GDP) in Venezuela in 2005 to that in 2006?
Give a very brief answer. 0.78. What is the ratio of the Domestic credit (% of GDP) in Comoros in 2005 to that in 2007?
Provide a succinct answer. 0.97. What is the ratio of the Domestic credit (% of GDP) in Sierra Leone in 2005 to that in 2007?
Your answer should be compact. 0.76. What is the ratio of the Domestic credit (% of GDP) of Solomon Islands in 2005 to that in 2007?
Keep it short and to the point. 0.52. What is the ratio of the Domestic credit (% of GDP) of Venezuela in 2005 to that in 2007?
Your answer should be very brief. 0.56. What is the ratio of the Domestic credit (% of GDP) of Comoros in 2005 to that in 2008?
Your response must be concise. 0.8. What is the ratio of the Domestic credit (% of GDP) in Sierra Leone in 2005 to that in 2008?
Make the answer very short. 0.59. What is the ratio of the Domestic credit (% of GDP) of Solomon Islands in 2005 to that in 2008?
Offer a terse response. 0.49. What is the ratio of the Domestic credit (% of GDP) in Venezuela in 2005 to that in 2008?
Give a very brief answer. 0.61. What is the ratio of the Domestic credit (% of GDP) of Comoros in 2005 to that in 2009?
Give a very brief answer. 0.58. What is the ratio of the Domestic credit (% of GDP) of Sierra Leone in 2005 to that in 2009?
Your answer should be compact. 0.4. What is the ratio of the Domestic credit (% of GDP) in Solomon Islands in 2005 to that in 2009?
Offer a very short reply. 0.52. What is the ratio of the Domestic credit (% of GDP) in Venezuela in 2005 to that in 2009?
Offer a terse response. 0.56. What is the ratio of the Domestic credit (% of GDP) of Comoros in 2005 to that in 2010?
Provide a short and direct response. 0.49. What is the ratio of the Domestic credit (% of GDP) in Sierra Leone in 2005 to that in 2010?
Your answer should be compact. 0.42. What is the ratio of the Domestic credit (% of GDP) of Solomon Islands in 2005 to that in 2010?
Provide a succinct answer. 0.62. What is the ratio of the Domestic credit (% of GDP) in Comoros in 2005 to that in 2011?
Your answer should be compact. 0.47. What is the ratio of the Domestic credit (% of GDP) of Sierra Leone in 2005 to that in 2011?
Keep it short and to the point. 0.42. What is the ratio of the Domestic credit (% of GDP) of Solomon Islands in 2005 to that in 2011?
Your response must be concise. 0.74. What is the ratio of the Domestic credit (% of GDP) in Venezuela in 2005 to that in 2011?
Offer a very short reply. 0.65. What is the ratio of the Domestic credit (% of GDP) in Comoros in 2006 to that in 2007?
Offer a terse response. 0.92. What is the ratio of the Domestic credit (% of GDP) of Sierra Leone in 2006 to that in 2007?
Your response must be concise. 0.78. What is the ratio of the Domestic credit (% of GDP) in Solomon Islands in 2006 to that in 2007?
Your answer should be compact. 0.74. What is the ratio of the Domestic credit (% of GDP) of Venezuela in 2006 to that in 2007?
Offer a terse response. 0.72. What is the ratio of the Domestic credit (% of GDP) of Comoros in 2006 to that in 2008?
Give a very brief answer. 0.75. What is the ratio of the Domestic credit (% of GDP) in Sierra Leone in 2006 to that in 2008?
Keep it short and to the point. 0.6. What is the ratio of the Domestic credit (% of GDP) in Solomon Islands in 2006 to that in 2008?
Offer a terse response. 0.7. What is the ratio of the Domestic credit (% of GDP) of Venezuela in 2006 to that in 2008?
Offer a very short reply. 0.79. What is the ratio of the Domestic credit (% of GDP) of Comoros in 2006 to that in 2009?
Give a very brief answer. 0.55. What is the ratio of the Domestic credit (% of GDP) of Sierra Leone in 2006 to that in 2009?
Ensure brevity in your answer.  0.41. What is the ratio of the Domestic credit (% of GDP) of Solomon Islands in 2006 to that in 2009?
Ensure brevity in your answer.  0.74. What is the ratio of the Domestic credit (% of GDP) in Venezuela in 2006 to that in 2009?
Keep it short and to the point. 0.72. What is the ratio of the Domestic credit (% of GDP) in Comoros in 2006 to that in 2010?
Offer a terse response. 0.46. What is the ratio of the Domestic credit (% of GDP) of Sierra Leone in 2006 to that in 2010?
Keep it short and to the point. 0.43. What is the ratio of the Domestic credit (% of GDP) of Solomon Islands in 2006 to that in 2010?
Keep it short and to the point. 0.88. What is the ratio of the Domestic credit (% of GDP) in Venezuela in 2006 to that in 2010?
Your answer should be compact. 0.9. What is the ratio of the Domestic credit (% of GDP) in Comoros in 2006 to that in 2011?
Keep it short and to the point. 0.44. What is the ratio of the Domestic credit (% of GDP) in Sierra Leone in 2006 to that in 2011?
Your answer should be very brief. 0.43. What is the ratio of the Domestic credit (% of GDP) of Solomon Islands in 2006 to that in 2011?
Offer a terse response. 1.05. What is the ratio of the Domestic credit (% of GDP) in Venezuela in 2006 to that in 2011?
Your response must be concise. 0.83. What is the ratio of the Domestic credit (% of GDP) of Comoros in 2007 to that in 2008?
Your answer should be compact. 0.82. What is the ratio of the Domestic credit (% of GDP) of Sierra Leone in 2007 to that in 2008?
Make the answer very short. 0.77. What is the ratio of the Domestic credit (% of GDP) in Solomon Islands in 2007 to that in 2008?
Provide a succinct answer. 0.94. What is the ratio of the Domestic credit (% of GDP) of Venezuela in 2007 to that in 2008?
Make the answer very short. 1.09. What is the ratio of the Domestic credit (% of GDP) in Comoros in 2007 to that in 2009?
Offer a terse response. 0.6. What is the ratio of the Domestic credit (% of GDP) of Sierra Leone in 2007 to that in 2009?
Ensure brevity in your answer.  0.53. What is the ratio of the Domestic credit (% of GDP) of Solomon Islands in 2007 to that in 2009?
Your answer should be very brief. 1.01. What is the ratio of the Domestic credit (% of GDP) in Comoros in 2007 to that in 2010?
Offer a terse response. 0.5. What is the ratio of the Domestic credit (% of GDP) of Sierra Leone in 2007 to that in 2010?
Make the answer very short. 0.55. What is the ratio of the Domestic credit (% of GDP) in Solomon Islands in 2007 to that in 2010?
Ensure brevity in your answer.  1.19. What is the ratio of the Domestic credit (% of GDP) in Venezuela in 2007 to that in 2010?
Offer a terse response. 1.25. What is the ratio of the Domestic credit (% of GDP) in Comoros in 2007 to that in 2011?
Your answer should be compact. 0.48. What is the ratio of the Domestic credit (% of GDP) of Sierra Leone in 2007 to that in 2011?
Make the answer very short. 0.55. What is the ratio of the Domestic credit (% of GDP) of Solomon Islands in 2007 to that in 2011?
Your answer should be very brief. 1.42. What is the ratio of the Domestic credit (% of GDP) of Venezuela in 2007 to that in 2011?
Ensure brevity in your answer.  1.15. What is the ratio of the Domestic credit (% of GDP) in Comoros in 2008 to that in 2009?
Make the answer very short. 0.73. What is the ratio of the Domestic credit (% of GDP) of Sierra Leone in 2008 to that in 2009?
Give a very brief answer. 0.68. What is the ratio of the Domestic credit (% of GDP) of Solomon Islands in 2008 to that in 2009?
Give a very brief answer. 1.07. What is the ratio of the Domestic credit (% of GDP) in Venezuela in 2008 to that in 2009?
Provide a succinct answer. 0.91. What is the ratio of the Domestic credit (% of GDP) of Comoros in 2008 to that in 2010?
Your response must be concise. 0.61. What is the ratio of the Domestic credit (% of GDP) of Sierra Leone in 2008 to that in 2010?
Offer a terse response. 0.71. What is the ratio of the Domestic credit (% of GDP) of Solomon Islands in 2008 to that in 2010?
Provide a short and direct response. 1.26. What is the ratio of the Domestic credit (% of GDP) in Venezuela in 2008 to that in 2010?
Your answer should be very brief. 1.14. What is the ratio of the Domestic credit (% of GDP) in Comoros in 2008 to that in 2011?
Your answer should be compact. 0.58. What is the ratio of the Domestic credit (% of GDP) of Sierra Leone in 2008 to that in 2011?
Offer a very short reply. 0.72. What is the ratio of the Domestic credit (% of GDP) in Solomon Islands in 2008 to that in 2011?
Keep it short and to the point. 1.5. What is the ratio of the Domestic credit (% of GDP) in Venezuela in 2008 to that in 2011?
Provide a short and direct response. 1.05. What is the ratio of the Domestic credit (% of GDP) in Comoros in 2009 to that in 2010?
Provide a short and direct response. 0.84. What is the ratio of the Domestic credit (% of GDP) in Sierra Leone in 2009 to that in 2010?
Make the answer very short. 1.05. What is the ratio of the Domestic credit (% of GDP) in Solomon Islands in 2009 to that in 2010?
Your answer should be compact. 1.18. What is the ratio of the Domestic credit (% of GDP) in Venezuela in 2009 to that in 2010?
Keep it short and to the point. 1.25. What is the ratio of the Domestic credit (% of GDP) of Comoros in 2009 to that in 2011?
Offer a terse response. 0.8. What is the ratio of the Domestic credit (% of GDP) of Sierra Leone in 2009 to that in 2011?
Your answer should be compact. 1.06. What is the ratio of the Domestic credit (% of GDP) of Solomon Islands in 2009 to that in 2011?
Ensure brevity in your answer.  1.41. What is the ratio of the Domestic credit (% of GDP) in Venezuela in 2009 to that in 2011?
Give a very brief answer. 1.16. What is the ratio of the Domestic credit (% of GDP) of Comoros in 2010 to that in 2011?
Make the answer very short. 0.96. What is the ratio of the Domestic credit (% of GDP) of Sierra Leone in 2010 to that in 2011?
Offer a very short reply. 1.01. What is the ratio of the Domestic credit (% of GDP) of Solomon Islands in 2010 to that in 2011?
Keep it short and to the point. 1.2. What is the ratio of the Domestic credit (% of GDP) in Venezuela in 2010 to that in 2011?
Your response must be concise. 0.92. What is the difference between the highest and the second highest Domestic credit (% of GDP) in Comoros?
Your answer should be compact. 0.78. What is the difference between the highest and the second highest Domestic credit (% of GDP) of Sierra Leone?
Offer a very short reply. 0.39. What is the difference between the highest and the second highest Domestic credit (% of GDP) in Solomon Islands?
Your answer should be very brief. 1.52. What is the difference between the highest and the second highest Domestic credit (% of GDP) of Venezuela?
Offer a very short reply. 0.13. What is the difference between the highest and the lowest Domestic credit (% of GDP) in Comoros?
Keep it short and to the point. 10.61. What is the difference between the highest and the lowest Domestic credit (% of GDP) in Sierra Leone?
Ensure brevity in your answer.  4.88. What is the difference between the highest and the lowest Domestic credit (% of GDP) of Solomon Islands?
Offer a terse response. 13.74. What is the difference between the highest and the lowest Domestic credit (% of GDP) of Venezuela?
Give a very brief answer. 10.39. 